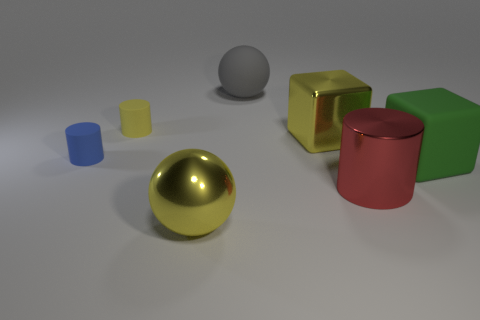Subtract all tiny cylinders. How many cylinders are left? 1 Subtract 2 cylinders. How many cylinders are left? 1 Subtract all red cylinders. How many cylinders are left? 2 Add 1 red things. How many objects exist? 8 Subtract all small rubber cylinders. Subtract all tiny yellow cylinders. How many objects are left? 4 Add 6 large gray matte spheres. How many large gray matte spheres are left? 7 Add 4 tiny cylinders. How many tiny cylinders exist? 6 Subtract 0 purple cylinders. How many objects are left? 7 Subtract all cylinders. How many objects are left? 4 Subtract all green cylinders. Subtract all green spheres. How many cylinders are left? 3 